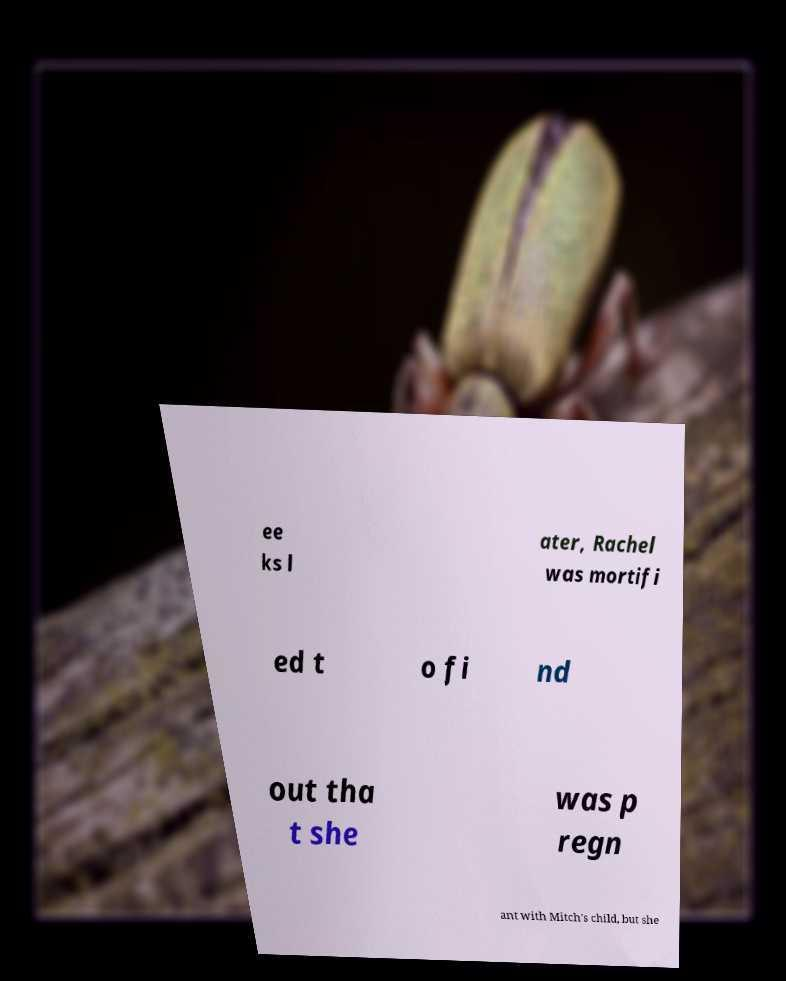For documentation purposes, I need the text within this image transcribed. Could you provide that? ee ks l ater, Rachel was mortifi ed t o fi nd out tha t she was p regn ant with Mitch's child, but she 